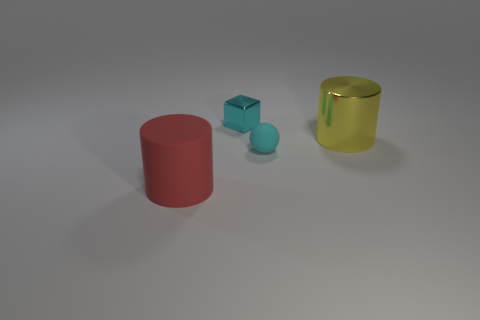Add 4 metal cylinders. How many objects exist? 8 Subtract all red cylinders. How many cylinders are left? 1 Subtract 1 cylinders. How many cylinders are left? 1 Subtract all small cylinders. Subtract all small cyan metal blocks. How many objects are left? 3 Add 1 metal cubes. How many metal cubes are left? 2 Add 2 gray matte cylinders. How many gray matte cylinders exist? 2 Subtract 0 brown blocks. How many objects are left? 4 Subtract all spheres. How many objects are left? 3 Subtract all green spheres. Subtract all gray cylinders. How many spheres are left? 1 Subtract all gray blocks. How many red balls are left? 0 